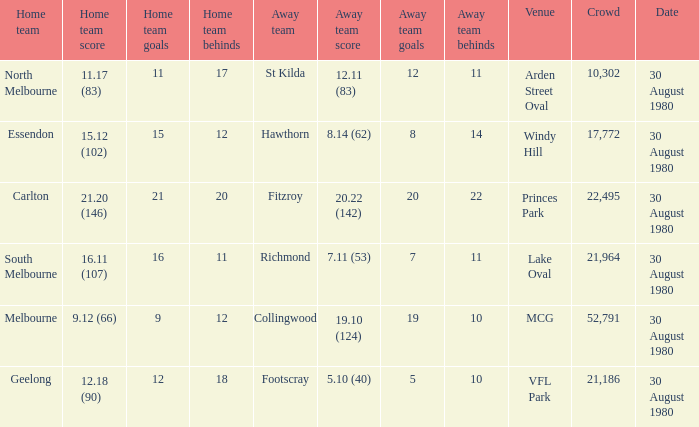What is the home team score at lake oval? 16.11 (107). 